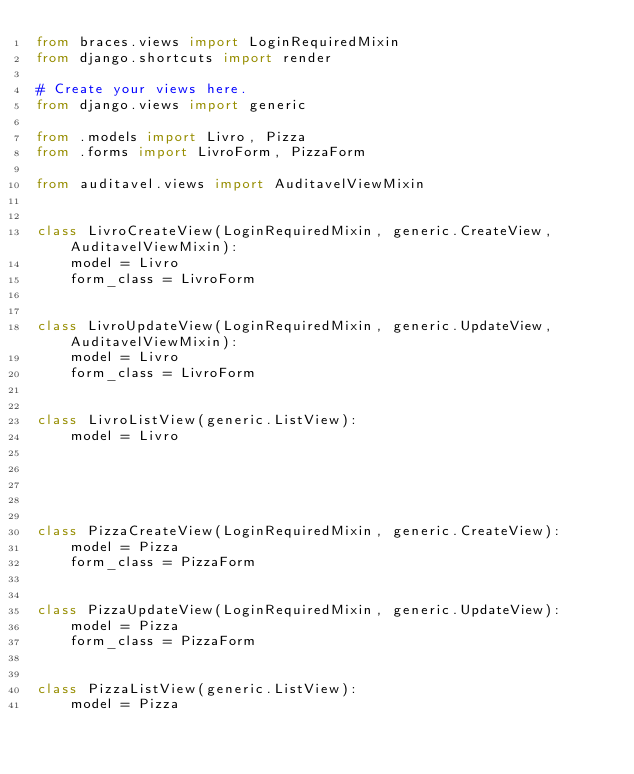Convert code to text. <code><loc_0><loc_0><loc_500><loc_500><_Python_>from braces.views import LoginRequiredMixin
from django.shortcuts import render

# Create your views here.
from django.views import generic

from .models import Livro, Pizza
from .forms import LivroForm, PizzaForm

from auditavel.views import AuditavelViewMixin


class LivroCreateView(LoginRequiredMixin, generic.CreateView, AuditavelViewMixin):
    model = Livro
    form_class = LivroForm


class LivroUpdateView(LoginRequiredMixin, generic.UpdateView, AuditavelViewMixin):
    model = Livro
    form_class = LivroForm


class LivroListView(generic.ListView):
    model = Livro





class PizzaCreateView(LoginRequiredMixin, generic.CreateView):
    model = Pizza
    form_class = PizzaForm


class PizzaUpdateView(LoginRequiredMixin, generic.UpdateView):
    model = Pizza
    form_class = PizzaForm


class PizzaListView(generic.ListView):
    model = Pizza
</code> 